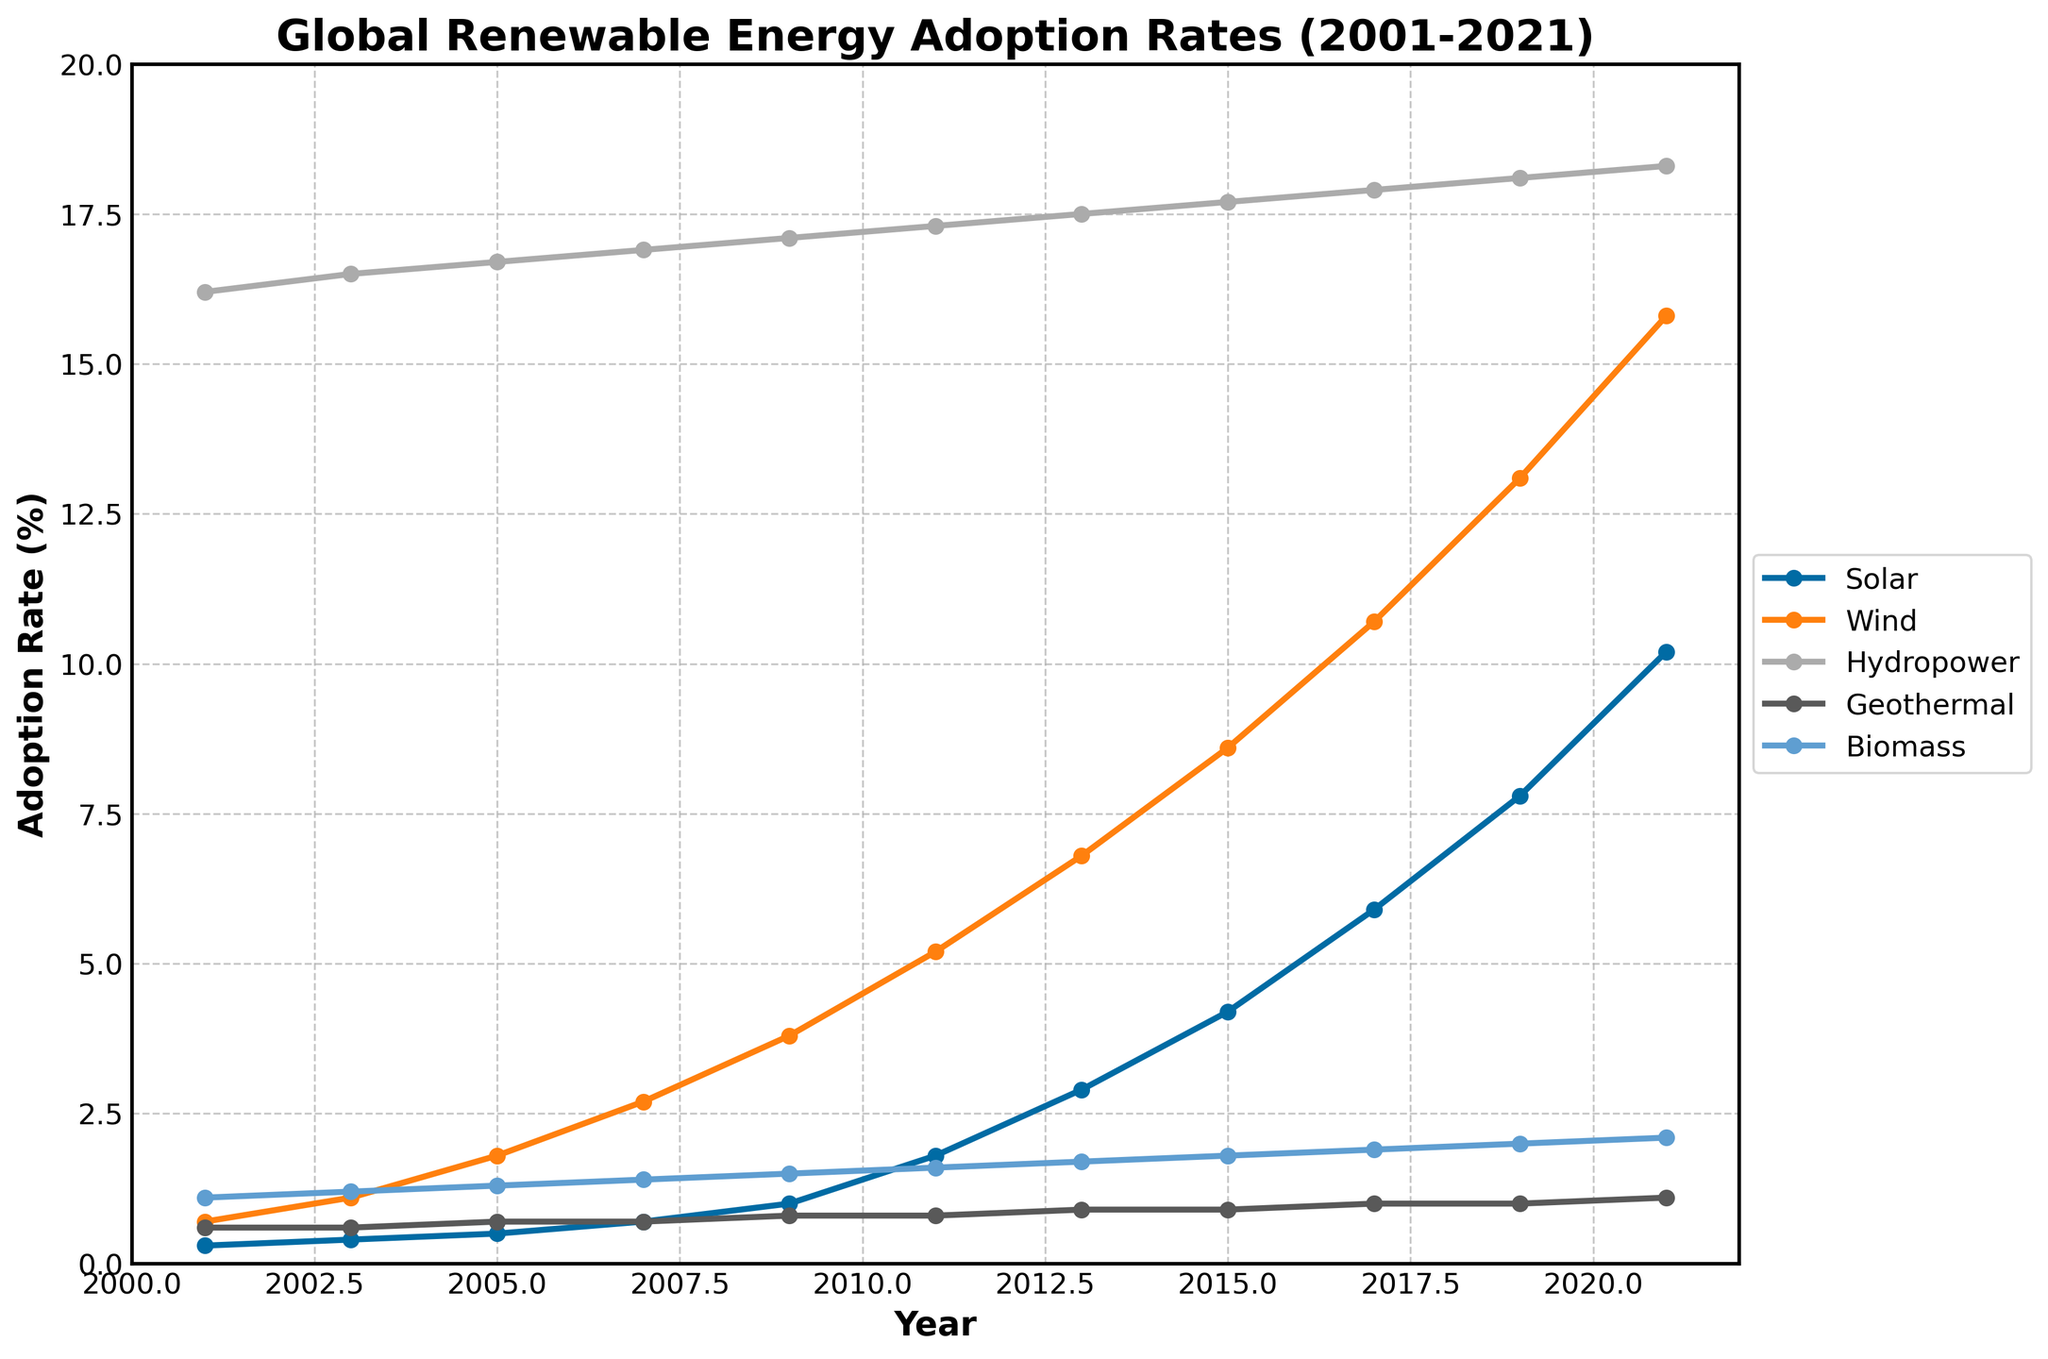What's the total increase in the adoption rate of Solar energy from 2001 to 2021? To calculate this, subtract the adoption rate of Solar energy in 2001 from the rate in 2021. From the figure, the rates are 0.3% in 2001 and 10.2% in 2021. Thus, the increase is 10.2 - 0.3 = 9.9%
Answer: 9.9% In what year did Wind energy adoption surpass 10%? To find this, locate the point where the Wind energy line crosses 10% on the y-axis. From the figure, Wind energy adoption surpasses 10% in 2017
Answer: 2017 Which renewable energy source had the smallest increase in adoption rate from 2001 to 2021? Compare the adoption rate increases for all renewable energy sources between 2001 and 2021. Hydropower increases from 16.2% to 18.3% (2.1%), Geothermal from 0.6% to 1.1% (0.5%), Biomass from 1.1% to 2.1% (1%), Wind from 0.7% to 15.8% (15.1%), and Solar from 0.3% to 10.2% (9.9%). The smallest increase is in Geothermal with 0.5%
Answer: Geothermal Compare the growth of Solar and Wind energy from 2001 to 2021. Which grew more and by how much? Calculate the increase for both energies: Solar grew from 0.3% to 10.2% (9.9%) and Wind from 0.7% to 15.8% (15.1%). Wind energy grew more, and the difference is 15.1% - 9.9% = 5.2%
Answer: Wind grew more by 5.2% What is the ratio of Biomass adoption to Geothermal adoption in 2021? In 2021, Biomass adoption is 2.1% and Geothermal is 1.1%. The ratio is 2.1 / 1.1
Answer: 1.9 What trend can be observed for Hydropower adoption over the 20 years? Inspect the Hydropower line from 2001 to 2021. The line is relatively flat, indicating very minimal increase from 16.2% to 18.3%. This suggests Hydropower has remained stable with slight growth
Answer: Stable with slight growth Was there any period where Solar energy adoption had a faster increase compared to other sources? Examine the slope of the Solar energy line and compare with other lines over different periods. The Solar energy line shows a sharp increase between 2011 and 2021, indicating faster growth during that period compared to others
Answer: 2011-2021 What is the average adoption rate for Hydropower over the 20 years? Add all the yearly adoption rates for Hydropower and divide by the number of years (11). The sum is: 16.2 + 16.5 + 16.7 + 16.9 + 17.1 + 17.3 + 17.5 + 17.7 + 17.9 + 18.1 + 18.3 = 194.2. The average is 194.2 / 11 ≈ 17.7%
Answer: 17.7% 